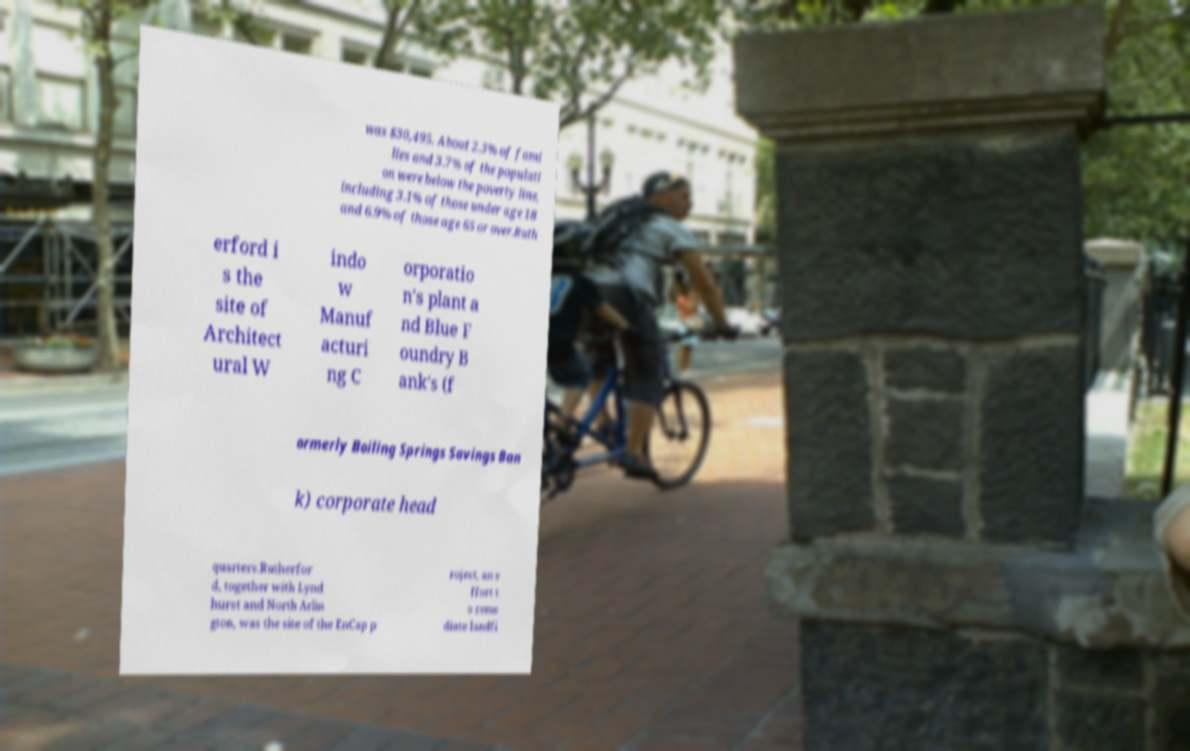Could you extract and type out the text from this image? was $30,495. About 2.3% of fami lies and 3.7% of the populati on were below the poverty line, including 3.1% of those under age 18 and 6.9% of those age 65 or over.Ruth erford i s the site of Architect ural W indo w Manuf acturi ng C orporatio n's plant a nd Blue F oundry B ank's (f ormerly Boiling Springs Savings Ban k) corporate head quarters.Rutherfor d, together with Lynd hurst and North Arlin gton, was the site of the EnCap p roject, an e ffort t o reme diate landfi 